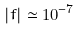Convert formula to latex. <formula><loc_0><loc_0><loc_500><loc_500>| f | \simeq 1 0 ^ { - 7 }</formula> 